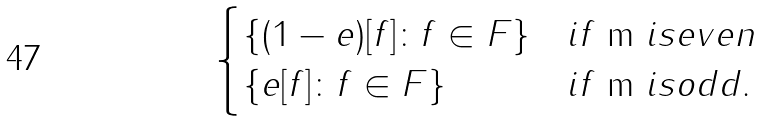Convert formula to latex. <formula><loc_0><loc_0><loc_500><loc_500>\begin{cases} \{ ( 1 - e ) [ f ] \colon f \in F \} & i f $ m $ i s e v e n \\ \{ e [ f ] \colon f \in F \} & i f $ m $ i s o d d . \end{cases}</formula> 